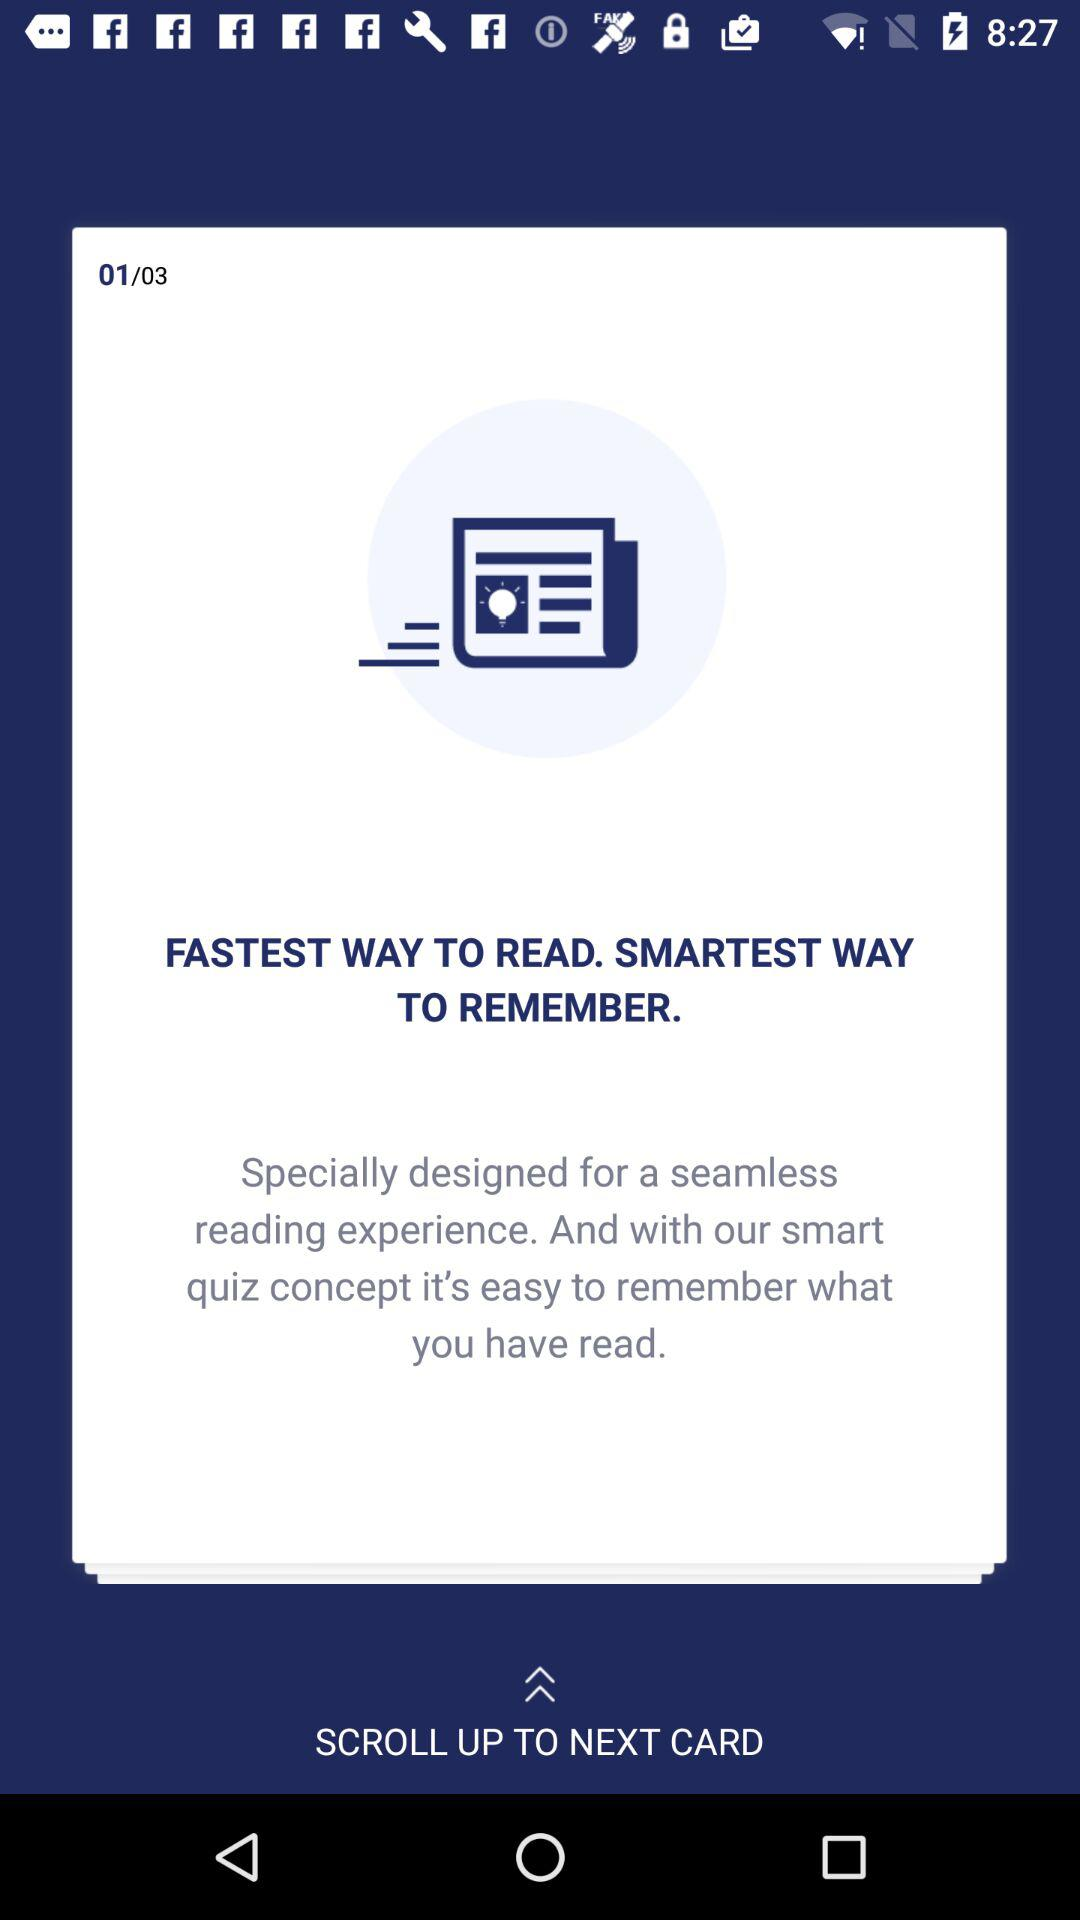What is the total number of cards? The total number of cards is 3. 